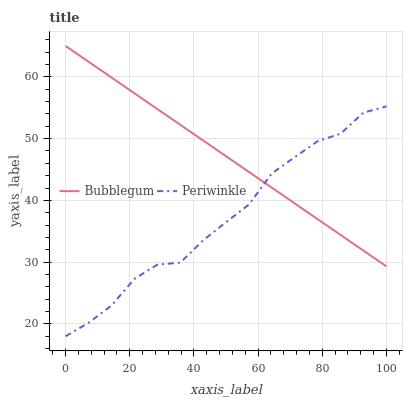Does Periwinkle have the minimum area under the curve?
Answer yes or no. Yes. Does Bubblegum have the maximum area under the curve?
Answer yes or no. Yes. Does Bubblegum have the minimum area under the curve?
Answer yes or no. No. Is Bubblegum the smoothest?
Answer yes or no. Yes. Is Periwinkle the roughest?
Answer yes or no. Yes. Is Bubblegum the roughest?
Answer yes or no. No. Does Bubblegum have the lowest value?
Answer yes or no. No. 